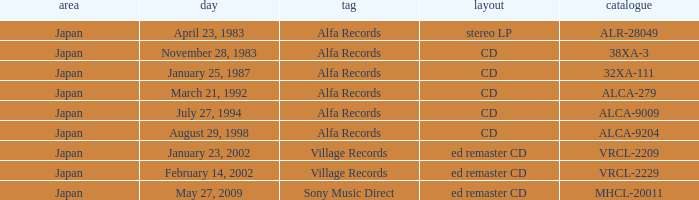Which catalog is in cd format? 38XA-3, 32XA-111, ALCA-279, ALCA-9009, ALCA-9204. 